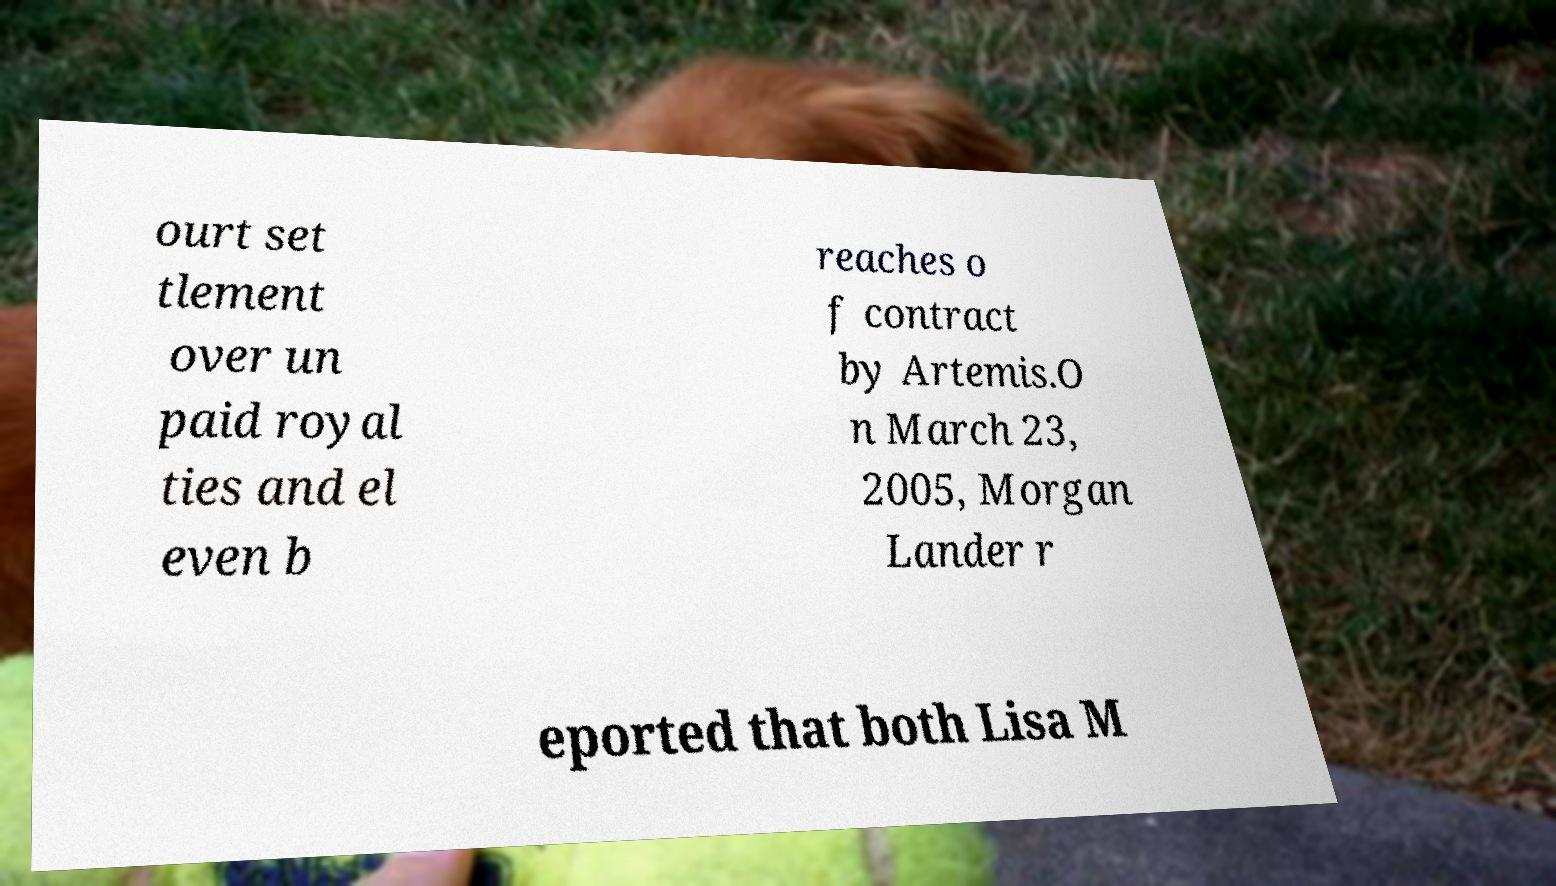What messages or text are displayed in this image? I need them in a readable, typed format. ourt set tlement over un paid royal ties and el even b reaches o f contract by Artemis.O n March 23, 2005, Morgan Lander r eported that both Lisa M 